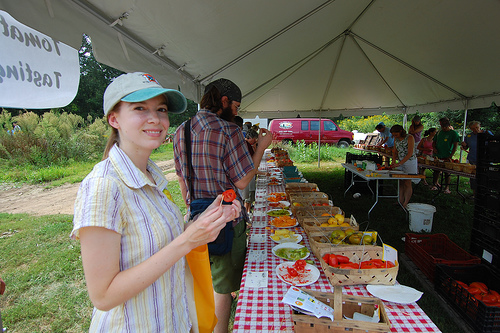<image>
Is the table to the left of the person? No. The table is not to the left of the person. From this viewpoint, they have a different horizontal relationship. 